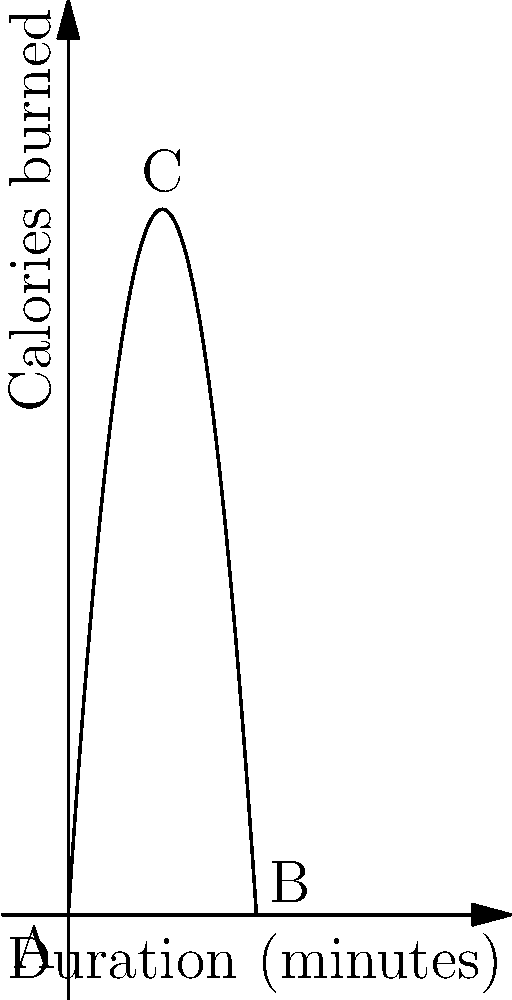As a Zumba instructor, you've noticed that the relationship between calories burned and the duration of a session follows a polynomial function. The graph shows this relationship, where the x-axis represents the duration of the session in minutes, and the y-axis represents the calories burned. The function is given by $f(x) = -0.5x^2 + 15x$, where $x$ is the duration in minutes. What is the maximum number of calories that can be burned in a single session, and at what duration does this occur? To find the maximum number of calories burned and the corresponding duration, we need to follow these steps:

1) The maximum point of a quadratic function occurs at the vertex of the parabola.

2) For a quadratic function in the form $f(x) = ax^2 + bx + c$, the x-coordinate of the vertex is given by $x = -\frac{b}{2a}$.

3) In our function $f(x) = -0.5x^2 + 15x$, we have $a = -0.5$ and $b = 15$.

4) Substituting into the formula:
   $x = -\frac{15}{2(-0.5)} = \frac{15}{1} = 15$

5) So the maximum occurs when the duration is 15 minutes.

6) To find the maximum number of calories, we substitute $x = 15$ into our original function:
   $f(15) = -0.5(15)^2 + 15(15)$
   $= -0.5(225) + 225$
   $= -112.5 + 225$
   $= 112.5$

Therefore, the maximum number of calories burned is 112.5, and this occurs when the session duration is 15 minutes.
Answer: 112.5 calories at 15 minutes 